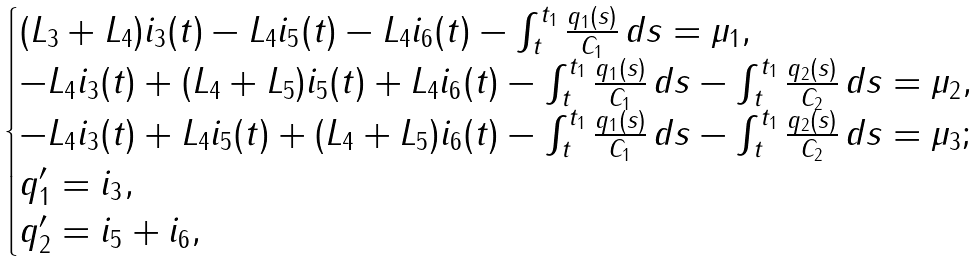Convert formula to latex. <formula><loc_0><loc_0><loc_500><loc_500>\begin{cases} ( L _ { 3 } + L _ { 4 } ) i _ { 3 } ( t ) - L _ { 4 } i _ { 5 } ( t ) - L _ { 4 } i _ { 6 } ( t ) - \int _ { t } ^ { t _ { 1 } } \frac { q _ { 1 } ( s ) } { C _ { 1 } } \, d s = \mu _ { 1 } , \\ - L _ { 4 } i _ { 3 } ( t ) + ( L _ { 4 } + L _ { 5 } ) i _ { 5 } ( t ) + L _ { 4 } i _ { 6 } ( t ) - \int _ { t } ^ { t _ { 1 } } \frac { q _ { 1 } ( s ) } { C _ { 1 } } \, d s - \int _ { t } ^ { t _ { 1 } } \frac { q _ { 2 } ( s ) } { C _ { 2 } } \, d s = \mu _ { 2 } , \\ - L _ { 4 } i _ { 3 } ( t ) + L _ { 4 } i _ { 5 } ( t ) + ( L _ { 4 } + L _ { 5 } ) i _ { 6 } ( t ) - \int _ { t } ^ { t _ { 1 } } \frac { q _ { 1 } ( s ) } { C _ { 1 } } \, d s - \int _ { t } ^ { t _ { 1 } } \frac { q _ { 2 } ( s ) } { C _ { 2 } } \, d s = \mu _ { 3 } ; \\ q _ { 1 } ^ { \prime } = i _ { 3 } , \\ q _ { 2 } ^ { \prime } = i _ { 5 } + i _ { 6 } , \end{cases}</formula> 